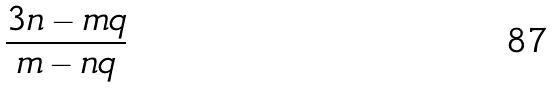Convert formula to latex. <formula><loc_0><loc_0><loc_500><loc_500>\frac { 3 n - m q } { m - n q }</formula> 